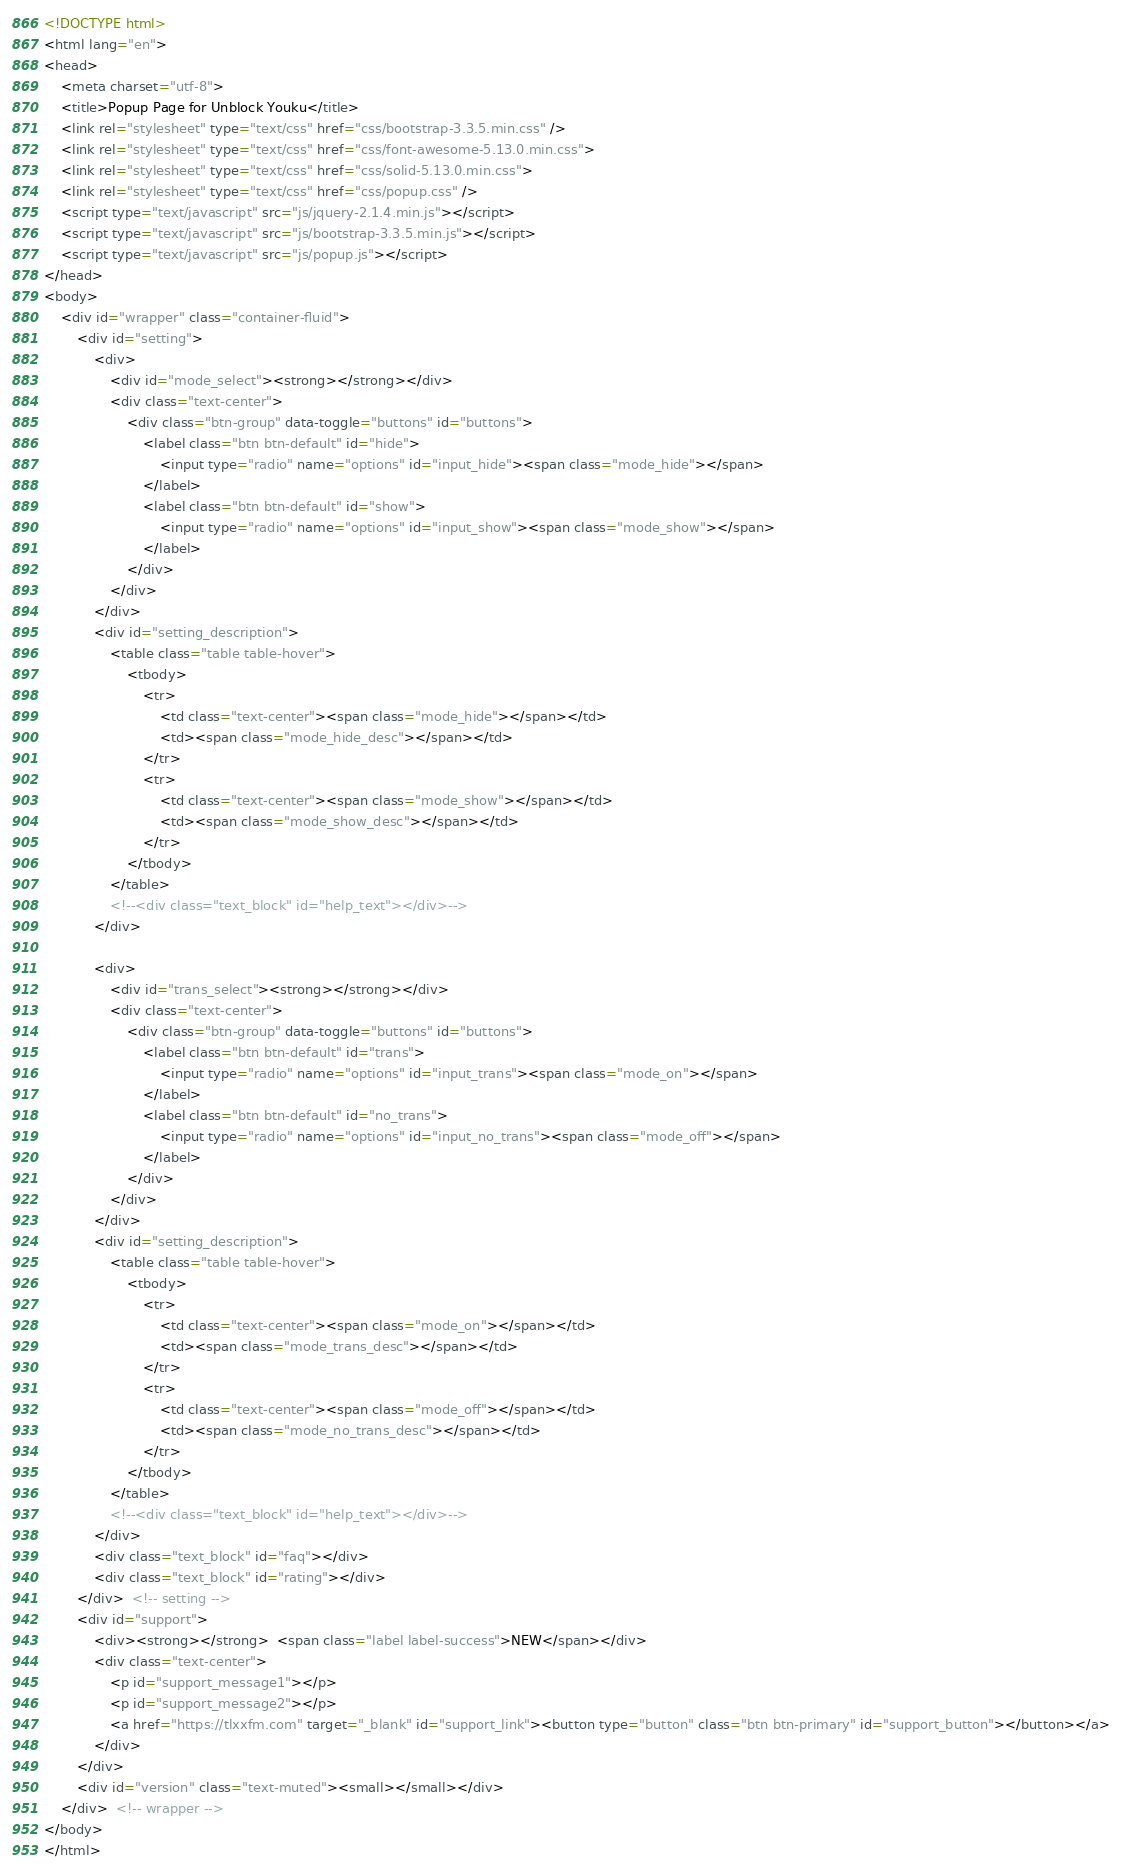Convert code to text. <code><loc_0><loc_0><loc_500><loc_500><_HTML_><!DOCTYPE html>
<html lang="en">
<head>
    <meta charset="utf-8">
    <title>Popup Page for Unblock Youku</title>
    <link rel="stylesheet" type="text/css" href="css/bootstrap-3.3.5.min.css" />
    <link rel="stylesheet" type="text/css" href="css/font-awesome-5.13.0.min.css">
    <link rel="stylesheet" type="text/css" href="css/solid-5.13.0.min.css">
    <link rel="stylesheet" type="text/css" href="css/popup.css" />
    <script type="text/javascript" src="js/jquery-2.1.4.min.js"></script>
    <script type="text/javascript" src="js/bootstrap-3.3.5.min.js"></script>
    <script type="text/javascript" src="js/popup.js"></script>
</head>
<body>
    <div id="wrapper" class="container-fluid">
        <div id="setting">
            <div>
                <div id="mode_select"><strong></strong></div>
                <div class="text-center">
                    <div class="btn-group" data-toggle="buttons" id="buttons">
                        <label class="btn btn-default" id="hide">
                            <input type="radio" name="options" id="input_hide"><span class="mode_hide"></span>
                        </label>
                        <label class="btn btn-default" id="show">
                            <input type="radio" name="options" id="input_show"><span class="mode_show"></span>
                        </label>
                    </div>
                </div>
            </div>
            <div id="setting_description">
                <table class="table table-hover">
                    <tbody>
                        <tr>
                            <td class="text-center"><span class="mode_hide"></span></td>
                            <td><span class="mode_hide_desc"></span></td>
                        </tr>
                        <tr>
                            <td class="text-center"><span class="mode_show"></span></td>
                            <td><span class="mode_show_desc"></span></td>
                        </tr>
                    </tbody>
                </table>
                <!--<div class="text_block" id="help_text"></div>-->
            </div>

            <div>
                <div id="trans_select"><strong></strong></div>
                <div class="text-center">
                    <div class="btn-group" data-toggle="buttons" id="buttons">
                        <label class="btn btn-default" id="trans">
                            <input type="radio" name="options" id="input_trans"><span class="mode_on"></span>
                        </label>
                        <label class="btn btn-default" id="no_trans">
                            <input type="radio" name="options" id="input_no_trans"><span class="mode_off"></span>
                        </label>
                    </div>
                </div>
            </div>
            <div id="setting_description">
                <table class="table table-hover">
                    <tbody>
                        <tr>
                            <td class="text-center"><span class="mode_on"></span></td>
                            <td><span class="mode_trans_desc"></span></td>
                        </tr>
                        <tr>
                            <td class="text-center"><span class="mode_off"></span></td>
                            <td><span class="mode_no_trans_desc"></span></td>
                        </tr>
                    </tbody>
                </table>
                <!--<div class="text_block" id="help_text"></div>-->
            </div>
            <div class="text_block" id="faq"></div>
            <div class="text_block" id="rating"></div>
        </div>  <!-- setting -->
        <div id="support">
            <div><strong></strong>  <span class="label label-success">NEW</span></div>
            <div class="text-center">
                <p id="support_message1"></p>
                <p id="support_message2"></p>
                <a href="https://tlxxfm.com" target="_blank" id="support_link"><button type="button" class="btn btn-primary" id="support_button"></button></a>
            </div>
        </div>
        <div id="version" class="text-muted"><small></small></div>
    </div>  <!-- wrapper -->
</body>
</html>

</code> 